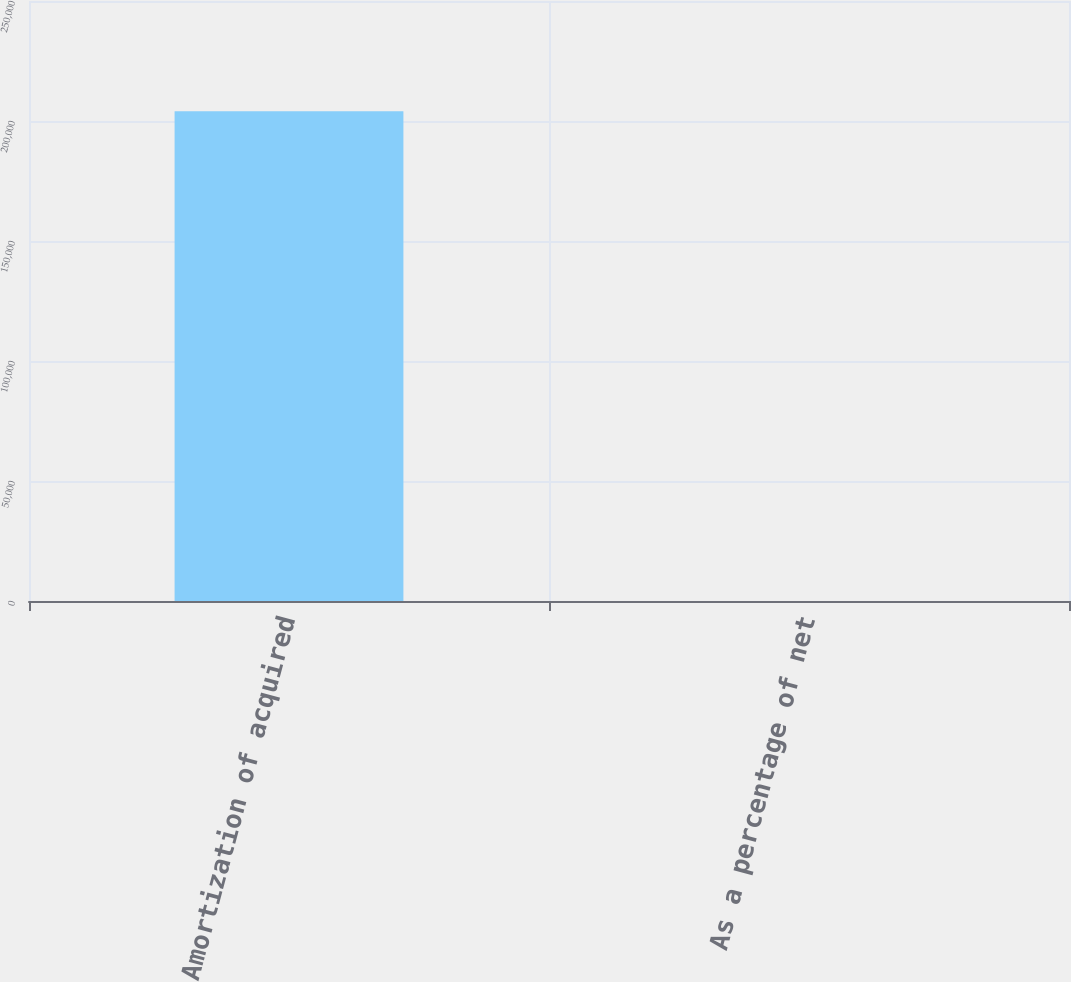Convert chart to OTSL. <chart><loc_0><loc_0><loc_500><loc_500><bar_chart><fcel>Amortization of acquired<fcel>As a percentage of net<nl><fcel>204104<fcel>2.7<nl></chart> 